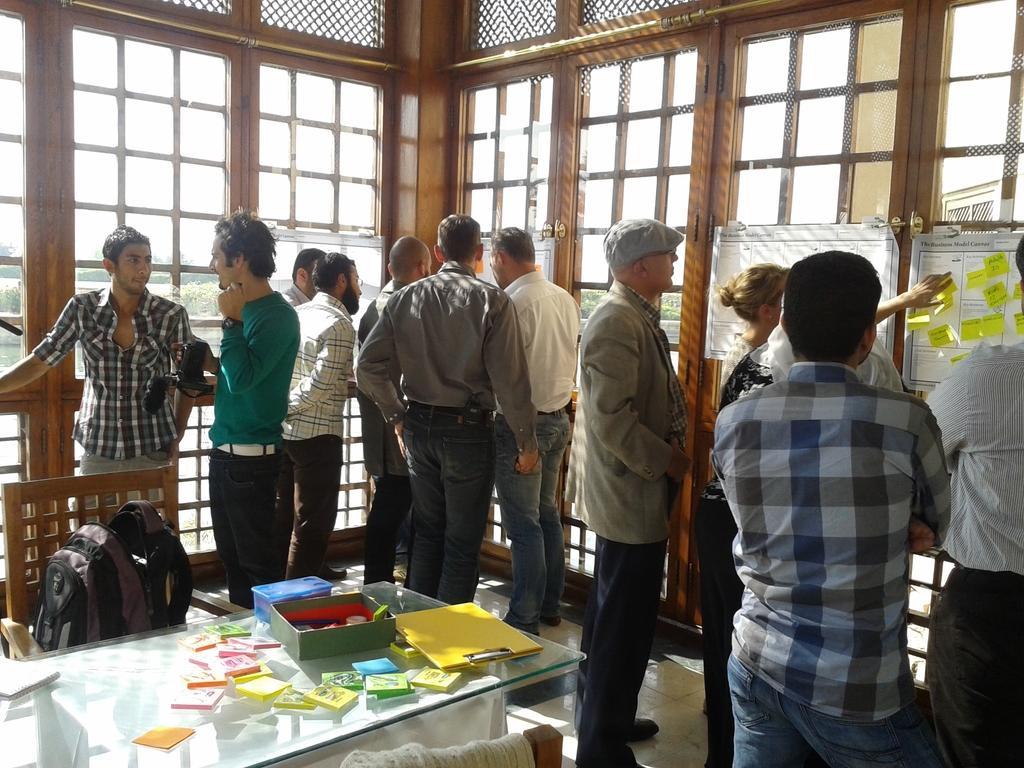Can you describe this image briefly? In the image we can see there are lot of people who are standing and on table there are booklets and pad. 